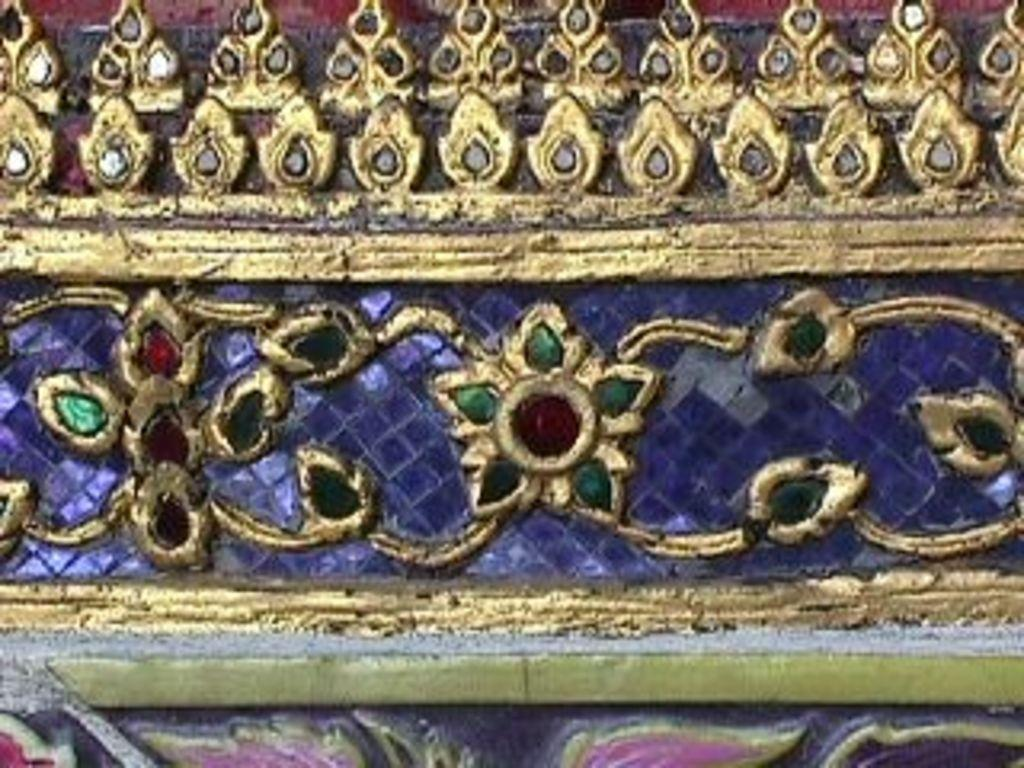What is depicted in the image? There is a design of flowers in the image. What material is the design carved on? The design is carved on a stone. What colors are used in the design? The design has gold, red, and green colors. Where is the vase placed in the image? There is no vase present in the image. What type of butter can be seen melting on the stone? There is no butter present in the image. 